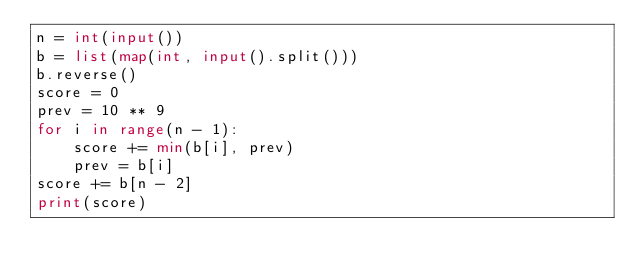Convert code to text. <code><loc_0><loc_0><loc_500><loc_500><_Python_>n = int(input())
b = list(map(int, input().split()))
b.reverse()
score = 0
prev = 10 ** 9
for i in range(n - 1):
    score += min(b[i], prev)
    prev = b[i]
score += b[n - 2]
print(score)</code> 